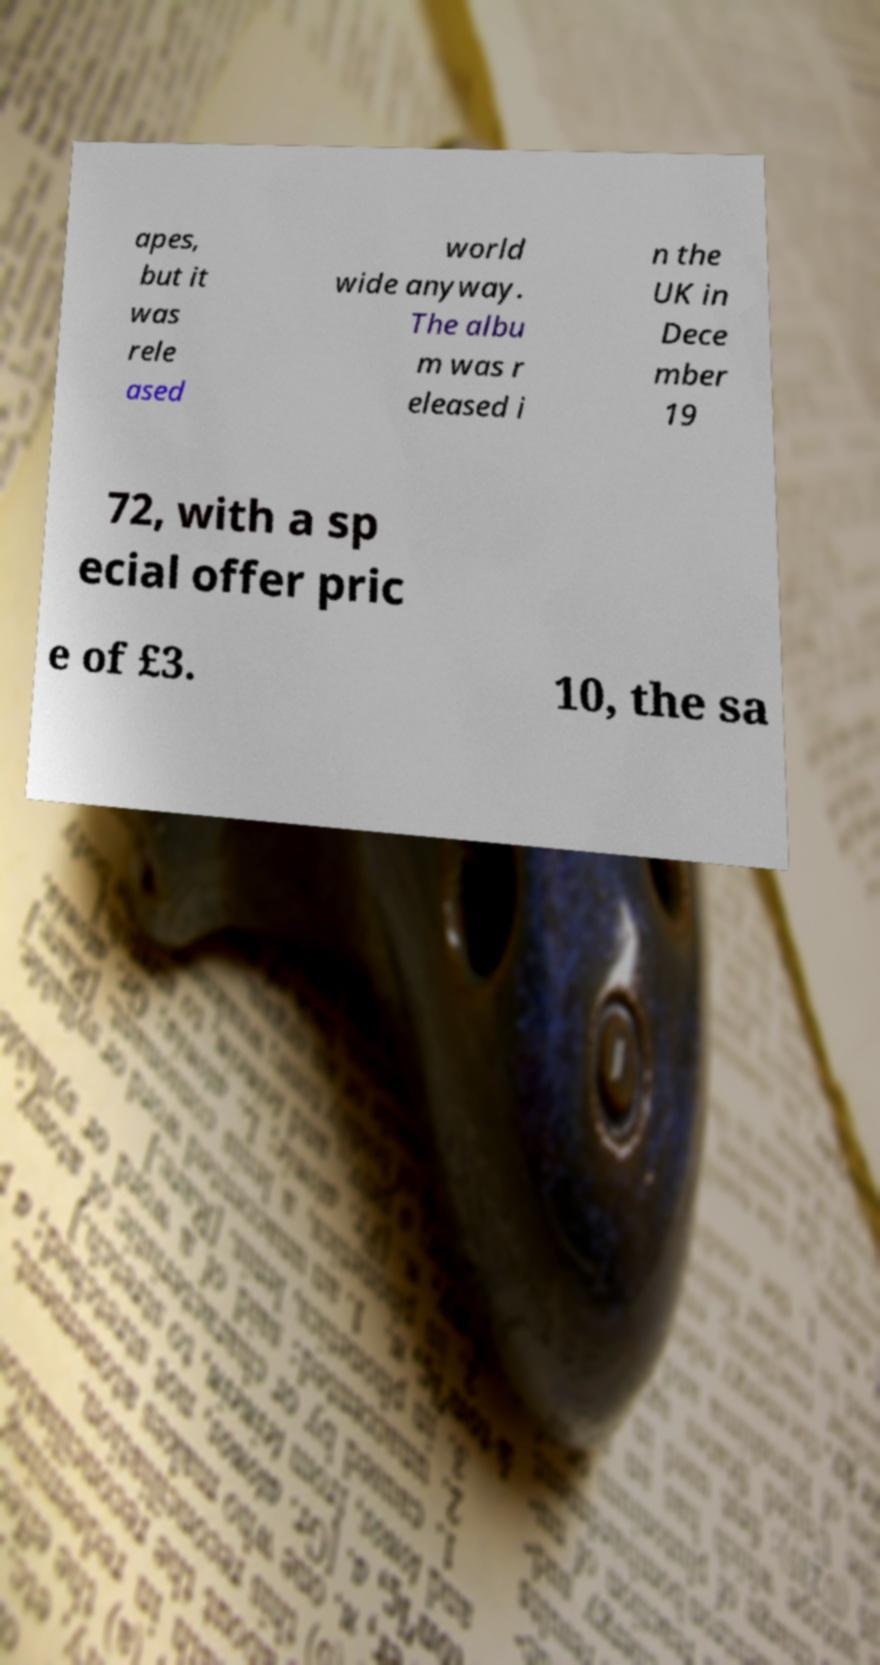Please read and relay the text visible in this image. What does it say? apes, but it was rele ased world wide anyway. The albu m was r eleased i n the UK in Dece mber 19 72, with a sp ecial offer pric e of £3. 10, the sa 